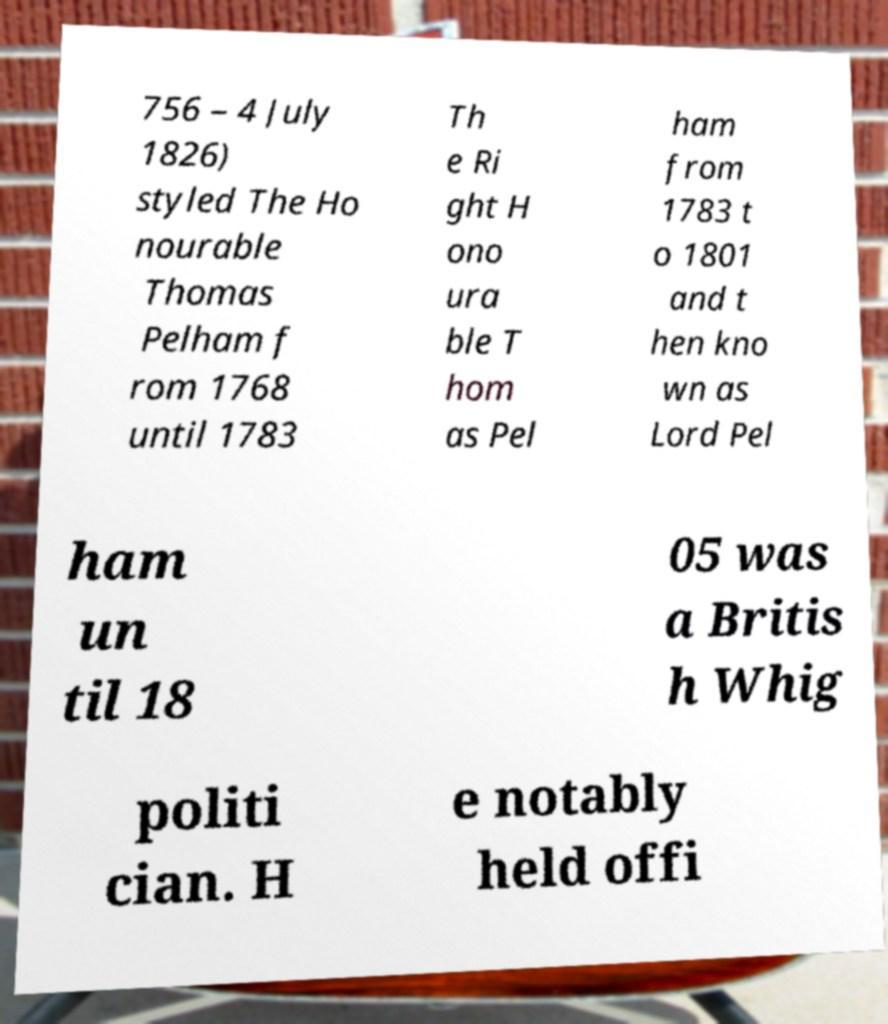Could you extract and type out the text from this image? 756 – 4 July 1826) styled The Ho nourable Thomas Pelham f rom 1768 until 1783 Th e Ri ght H ono ura ble T hom as Pel ham from 1783 t o 1801 and t hen kno wn as Lord Pel ham un til 18 05 was a Britis h Whig politi cian. H e notably held offi 